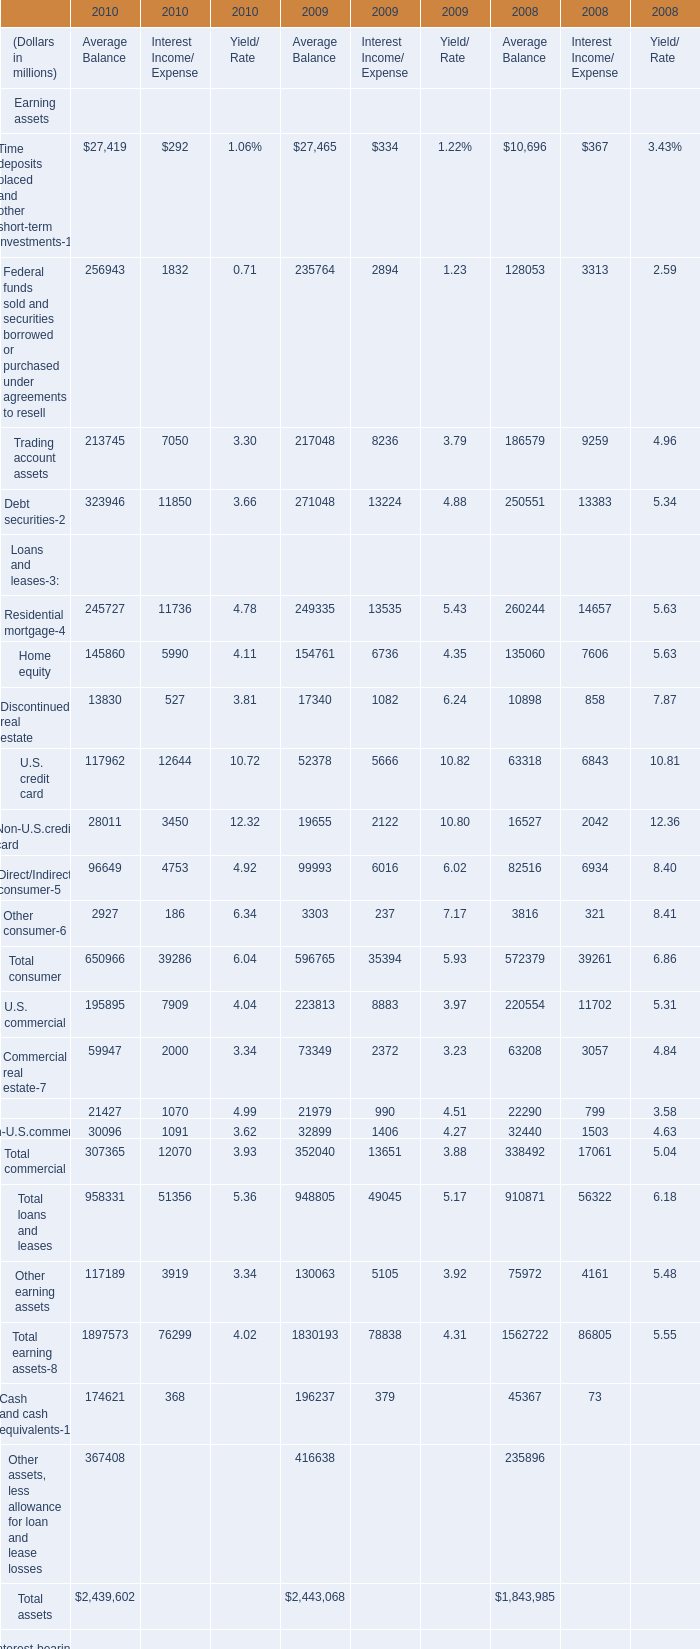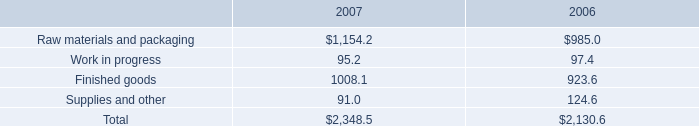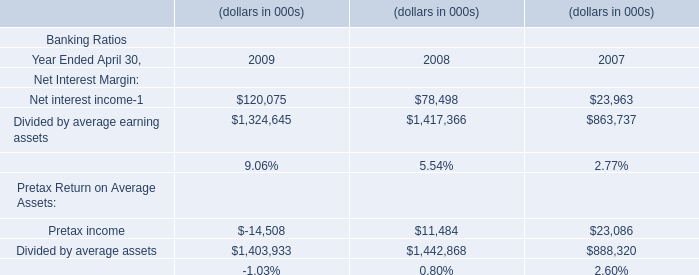Which year is Home equity in Average Balance the highest? 
Answer: 2009. 